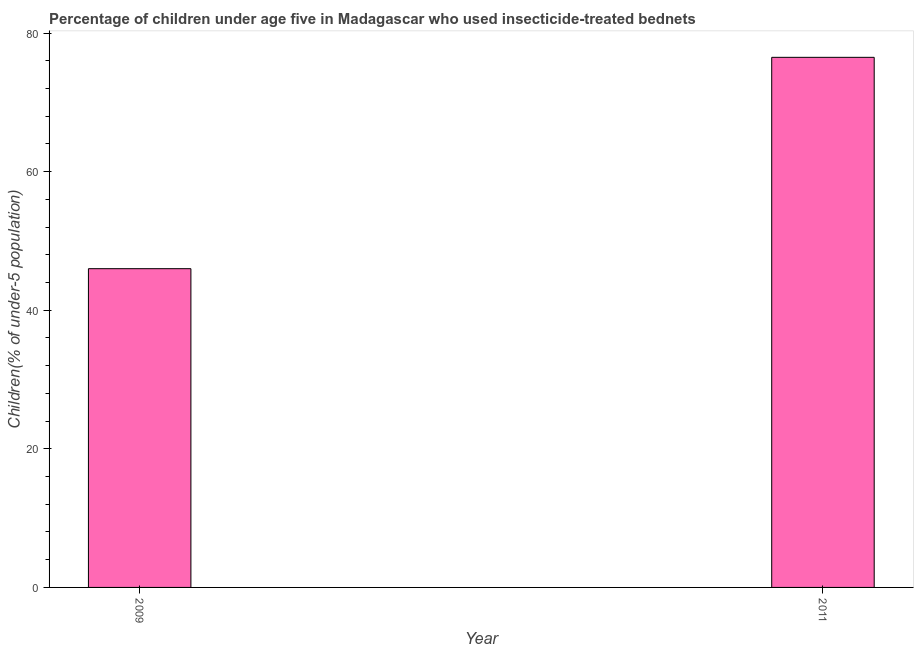What is the title of the graph?
Provide a succinct answer. Percentage of children under age five in Madagascar who used insecticide-treated bednets. What is the label or title of the Y-axis?
Give a very brief answer. Children(% of under-5 population). What is the percentage of children who use of insecticide-treated bed nets in 2011?
Your response must be concise. 76.5. Across all years, what is the maximum percentage of children who use of insecticide-treated bed nets?
Your answer should be very brief. 76.5. What is the sum of the percentage of children who use of insecticide-treated bed nets?
Offer a terse response. 122.5. What is the difference between the percentage of children who use of insecticide-treated bed nets in 2009 and 2011?
Ensure brevity in your answer.  -30.5. What is the average percentage of children who use of insecticide-treated bed nets per year?
Offer a terse response. 61.25. What is the median percentage of children who use of insecticide-treated bed nets?
Make the answer very short. 61.25. Do a majority of the years between 2009 and 2011 (inclusive) have percentage of children who use of insecticide-treated bed nets greater than 4 %?
Offer a terse response. Yes. What is the ratio of the percentage of children who use of insecticide-treated bed nets in 2009 to that in 2011?
Ensure brevity in your answer.  0.6. In how many years, is the percentage of children who use of insecticide-treated bed nets greater than the average percentage of children who use of insecticide-treated bed nets taken over all years?
Your response must be concise. 1. How many bars are there?
Offer a terse response. 2. Are all the bars in the graph horizontal?
Ensure brevity in your answer.  No. How many years are there in the graph?
Provide a succinct answer. 2. What is the difference between two consecutive major ticks on the Y-axis?
Make the answer very short. 20. Are the values on the major ticks of Y-axis written in scientific E-notation?
Provide a short and direct response. No. What is the Children(% of under-5 population) of 2011?
Offer a terse response. 76.5. What is the difference between the Children(% of under-5 population) in 2009 and 2011?
Your answer should be compact. -30.5. What is the ratio of the Children(% of under-5 population) in 2009 to that in 2011?
Offer a terse response. 0.6. 